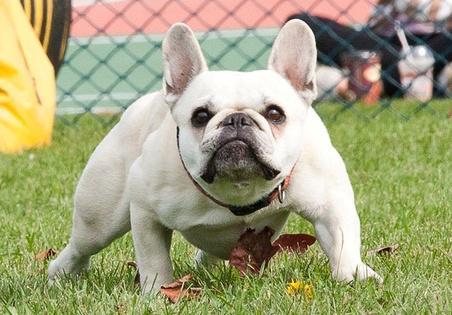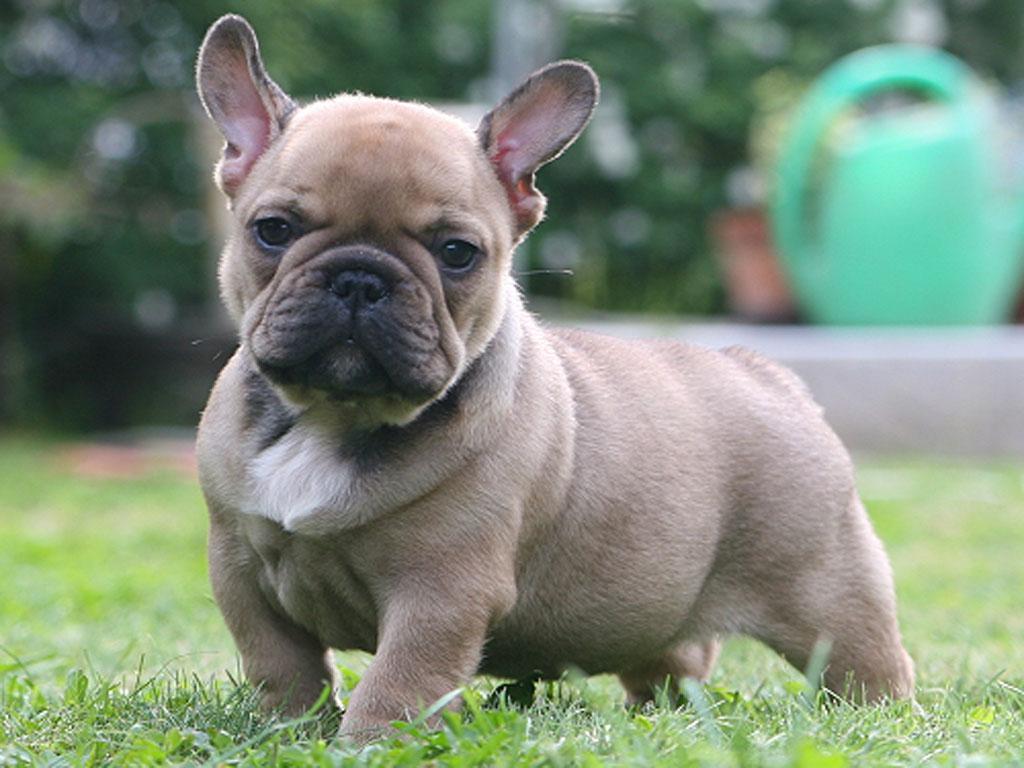The first image is the image on the left, the second image is the image on the right. For the images displayed, is the sentence "There is a bulldog with a small white patch of fur on his chest and all four of his feet are in the grass." factually correct? Answer yes or no. Yes. 